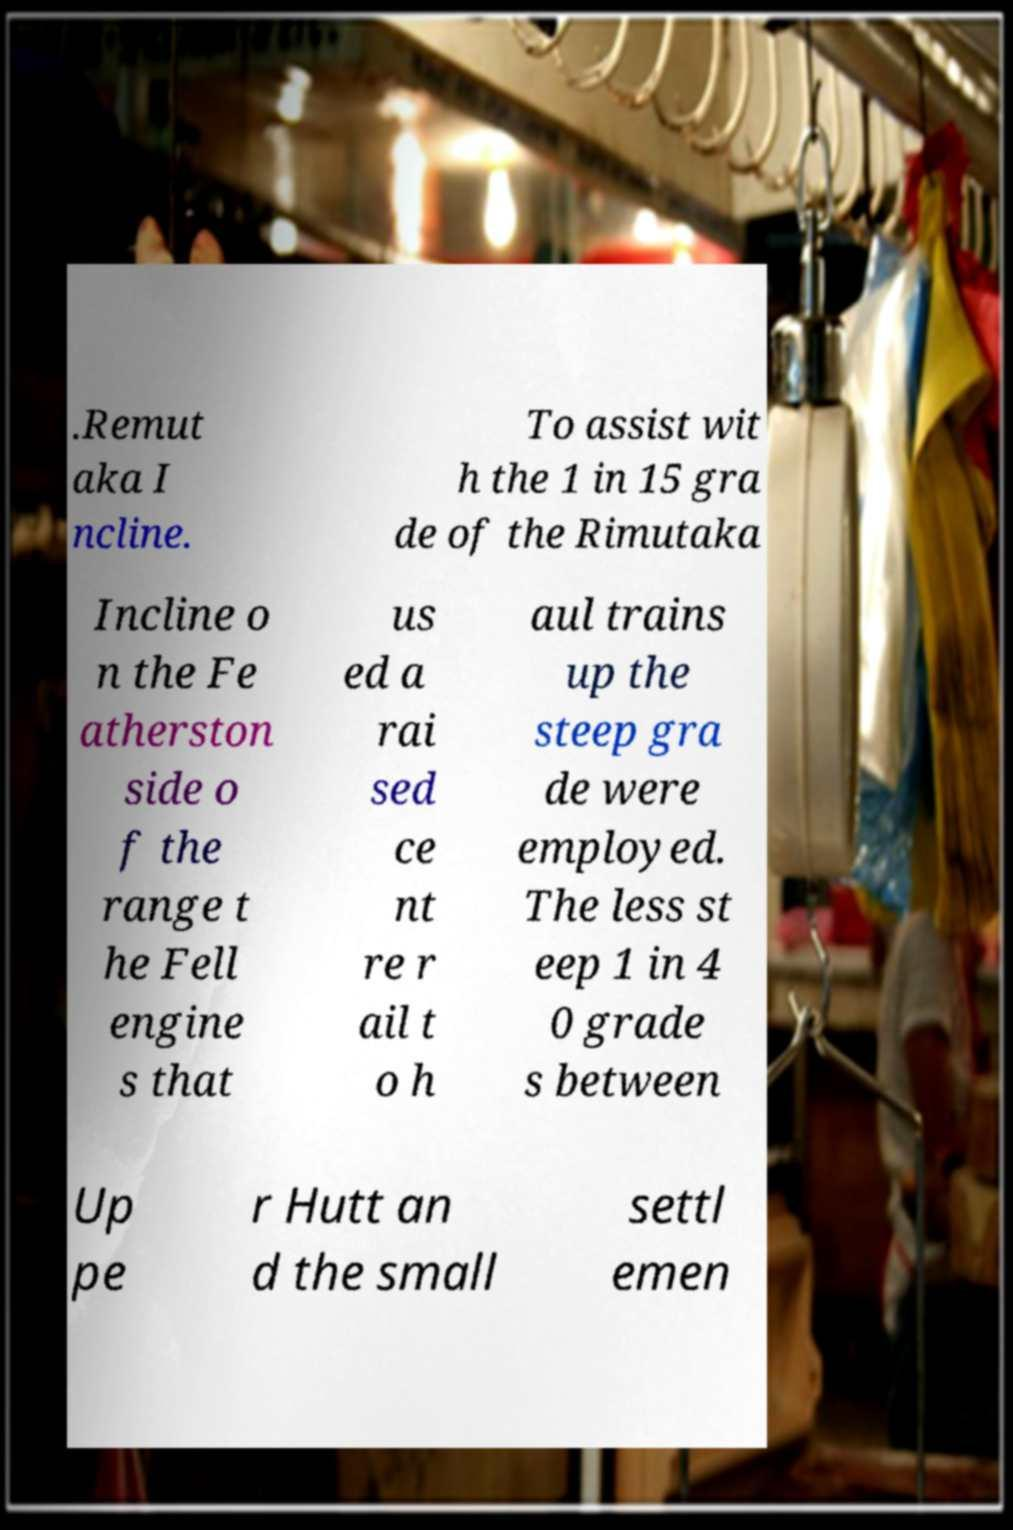Could you extract and type out the text from this image? .Remut aka I ncline. To assist wit h the 1 in 15 gra de of the Rimutaka Incline o n the Fe atherston side o f the range t he Fell engine s that us ed a rai sed ce nt re r ail t o h aul trains up the steep gra de were employed. The less st eep 1 in 4 0 grade s between Up pe r Hutt an d the small settl emen 